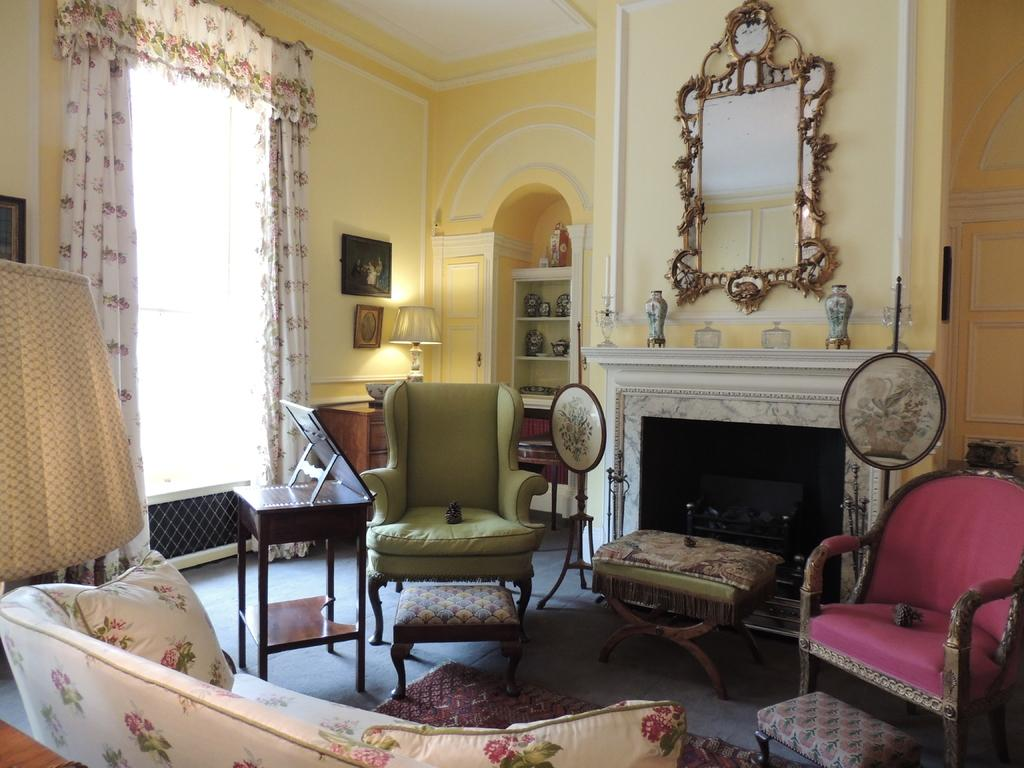How many chairs are visible in the image? There are many chairs in the image. What is the primary piece of furniture in the image? There is a table in the image. What can be seen near the window? There is a curtain associated with the window. What type of storage is present in the image? There is a rack in the image. What type of decorative items are present in the image? There are photo frames in the image. What type of team is visible in the image? There is no team present in the image. What material is the father made of in the image? There is no father present in the image. 